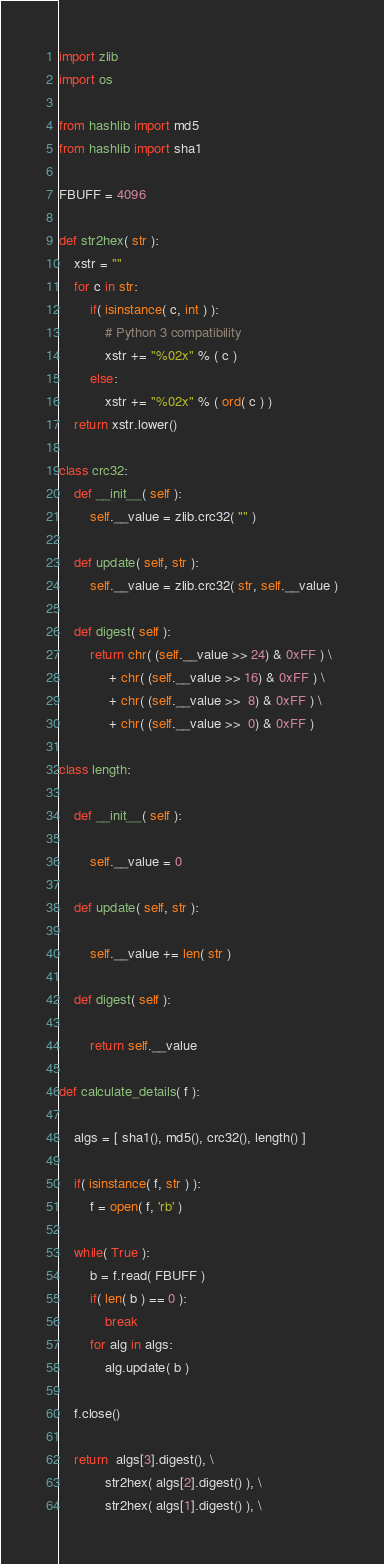Convert code to text. <code><loc_0><loc_0><loc_500><loc_500><_Python_>import zlib
import os

from hashlib import md5
from hashlib import sha1

FBUFF = 4096

def str2hex( str ):
    xstr = ""
    for c in str:
        if( isinstance( c, int ) ):
            # Python 3 compatibility
            xstr += "%02x" % ( c )
        else:
            xstr += "%02x" % ( ord( c ) )
    return xstr.lower()

class crc32:
    def __init__( self ):
        self.__value = zlib.crc32( "" )

    def update( self, str ):
        self.__value = zlib.crc32( str, self.__value )

    def digest( self ):
        return chr( (self.__value >> 24) & 0xFF ) \
             + chr( (self.__value >> 16) & 0xFF ) \
             + chr( (self.__value >>  8) & 0xFF ) \
             + chr( (self.__value >>  0) & 0xFF )

class length:

    def __init__( self ):

        self.__value = 0

    def update( self, str ):

        self.__value += len( str )

    def digest( self ):

        return self.__value

def calculate_details( f ):

    algs = [ sha1(), md5(), crc32(), length() ]

    if( isinstance( f, str ) ):
        f = open( f, 'rb' )

    while( True ):
        b = f.read( FBUFF )
        if( len( b ) == 0 ):
            break
        for alg in algs:
            alg.update( b )

    f.close()

    return  algs[3].digest(), \
            str2hex( algs[2].digest() ), \
            str2hex( algs[1].digest() ), \</code> 